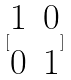Convert formula to latex. <formula><loc_0><loc_0><loc_500><loc_500>[ \begin{matrix} 1 & 0 \\ 0 & 1 \end{matrix} ]</formula> 